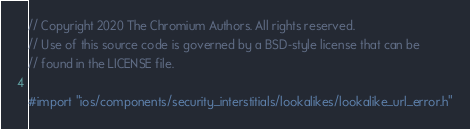<code> <loc_0><loc_0><loc_500><loc_500><_ObjectiveC_>// Copyright 2020 The Chromium Authors. All rights reserved.
// Use of this source code is governed by a BSD-style license that can be
// found in the LICENSE file.

#import "ios/components/security_interstitials/lookalikes/lookalike_url_error.h"
</code> 